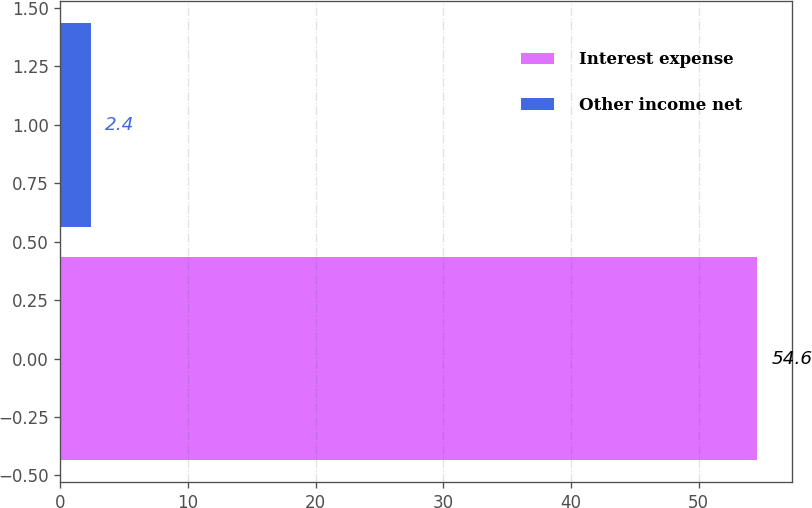Convert chart to OTSL. <chart><loc_0><loc_0><loc_500><loc_500><bar_chart><fcel>Interest expense<fcel>Other income net<nl><fcel>54.6<fcel>2.4<nl></chart> 